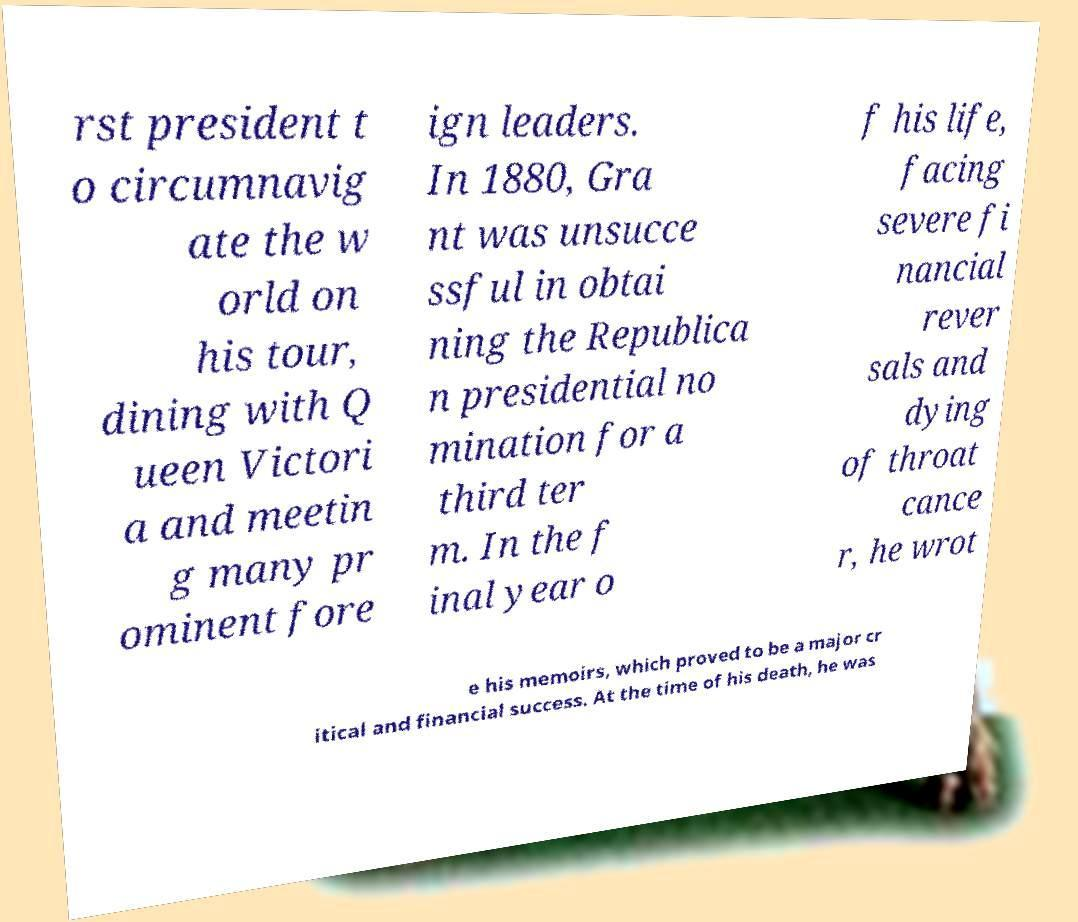What messages or text are displayed in this image? I need them in a readable, typed format. rst president t o circumnavig ate the w orld on his tour, dining with Q ueen Victori a and meetin g many pr ominent fore ign leaders. In 1880, Gra nt was unsucce ssful in obtai ning the Republica n presidential no mination for a third ter m. In the f inal year o f his life, facing severe fi nancial rever sals and dying of throat cance r, he wrot e his memoirs, which proved to be a major cr itical and financial success. At the time of his death, he was 